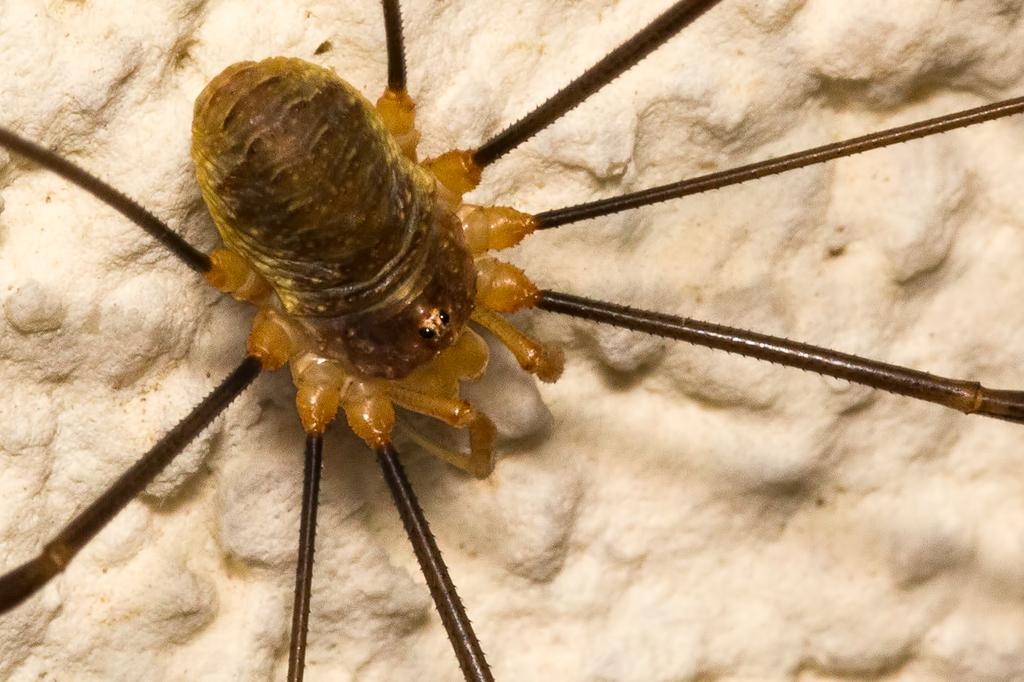What type of creature is in the picture? There is an insect in the picture. What color is the insect? The insect is brown in color. What is the color of the background in the image? The background of the image is white. What type of calculator is being used by the representative in the image? There is no calculator or representative present in the image; it features an insect on a white background. 